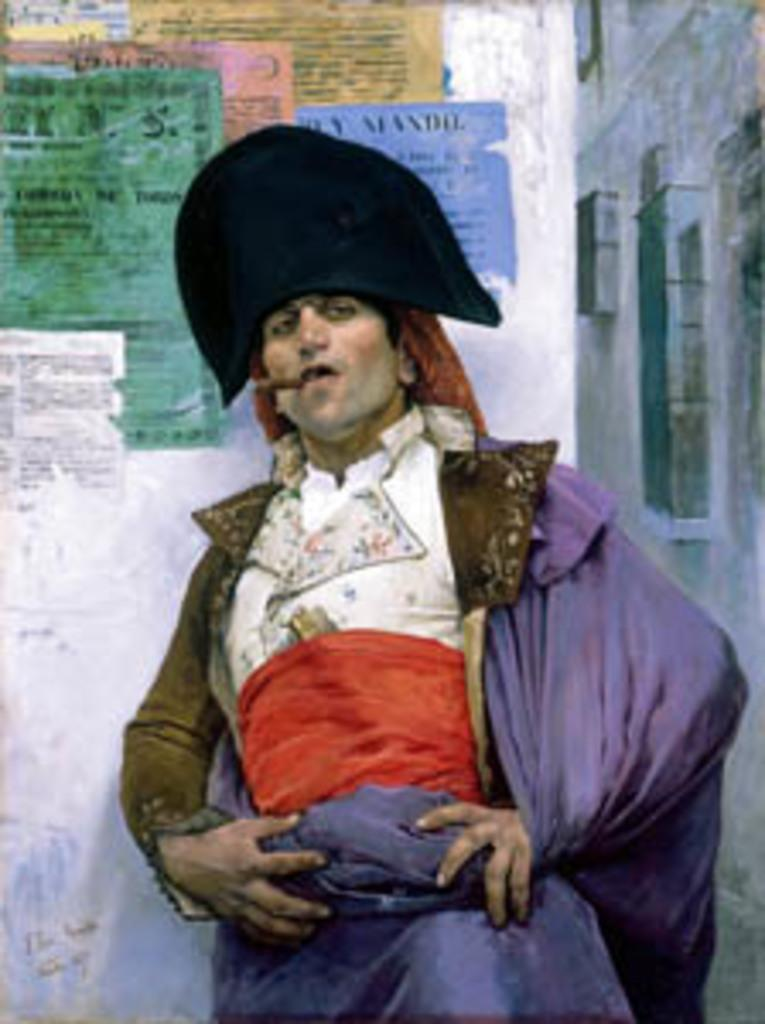Who is present in the image? There is a man in the image. What is the man wearing? The man is wearing a costume. What can be seen in the background of the image? There are walls visible in the background of the image. What is on the top of the image? There are papers on the top of the image. Is there any text or writing in the image? Yes, there is writing on the papers or somewhere in the image. How many holes can be seen in the man's costume in the image? There is no mention of any holes in the man's costume in the image. 